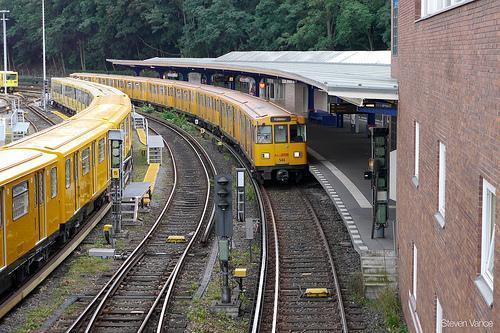How many tracks have trains on them?
Give a very brief answer. 2. 